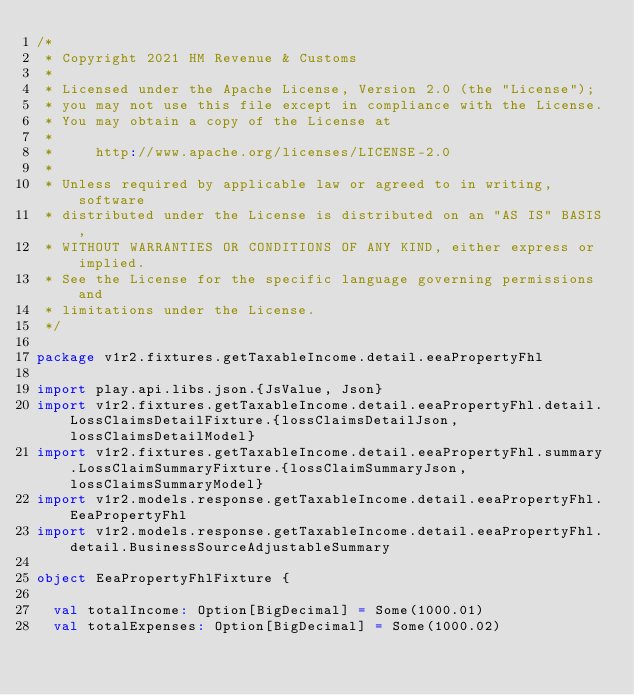<code> <loc_0><loc_0><loc_500><loc_500><_Scala_>/*
 * Copyright 2021 HM Revenue & Customs
 *
 * Licensed under the Apache License, Version 2.0 (the "License");
 * you may not use this file except in compliance with the License.
 * You may obtain a copy of the License at
 *
 *     http://www.apache.org/licenses/LICENSE-2.0
 *
 * Unless required by applicable law or agreed to in writing, software
 * distributed under the License is distributed on an "AS IS" BASIS,
 * WITHOUT WARRANTIES OR CONDITIONS OF ANY KIND, either express or implied.
 * See the License for the specific language governing permissions and
 * limitations under the License.
 */

package v1r2.fixtures.getTaxableIncome.detail.eeaPropertyFhl

import play.api.libs.json.{JsValue, Json}
import v1r2.fixtures.getTaxableIncome.detail.eeaPropertyFhl.detail.LossClaimsDetailFixture.{lossClaimsDetailJson, lossClaimsDetailModel}
import v1r2.fixtures.getTaxableIncome.detail.eeaPropertyFhl.summary.LossClaimSummaryFixture.{lossClaimSummaryJson, lossClaimsSummaryModel}
import v1r2.models.response.getTaxableIncome.detail.eeaPropertyFhl.EeaPropertyFhl
import v1r2.models.response.getTaxableIncome.detail.eeaPropertyFhl.detail.BusinessSourceAdjustableSummary

object EeaPropertyFhlFixture {

  val totalIncome: Option[BigDecimal] = Some(1000.01)
  val totalExpenses: Option[BigDecimal] = Some(1000.02)</code> 